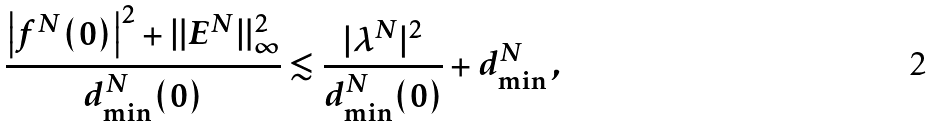Convert formula to latex. <formula><loc_0><loc_0><loc_500><loc_500>\frac { \left | f ^ { N } ( 0 ) \right | ^ { 2 } + \| E ^ { N } \| ^ { 2 } _ { \infty } } { d _ { \min } ^ { N } ( 0 ) } & \lesssim \frac { | \lambda ^ { N } | ^ { 2 } } { d _ { \min } ^ { N } ( 0 ) } + d _ { \min } ^ { N } \, ,</formula> 